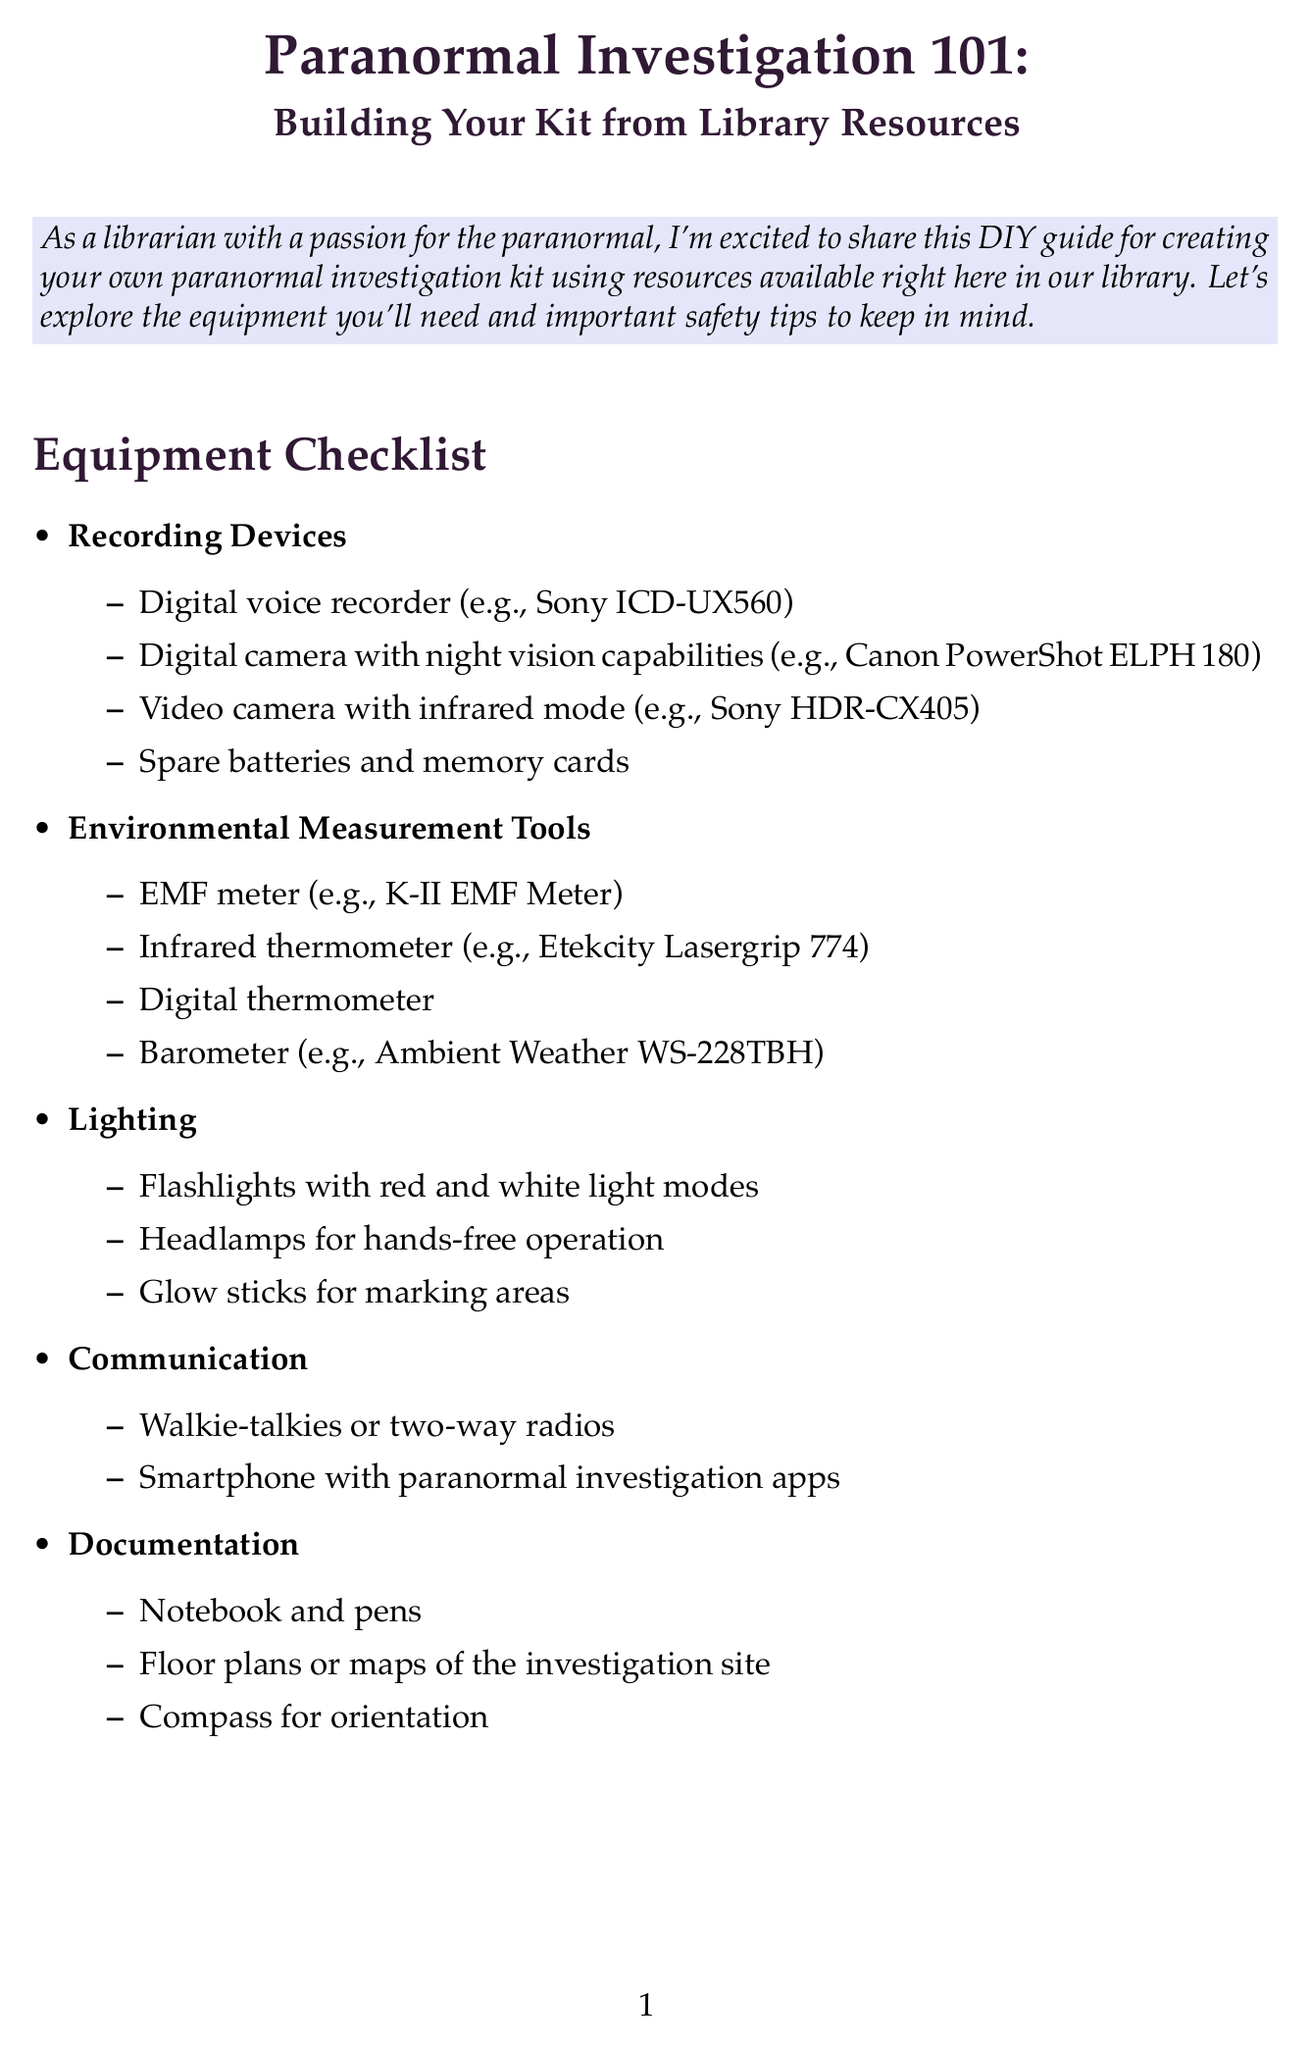What is the title of the newsletter? The title of the newsletter is prominently displayed at the beginning of the document.
Answer: Paranormal Investigation 101: Building Your Kit from Library Resources How many categories are in the equipment checklist? The equipment checklist is divided into categories, which are easily visible as section headers.
Answer: 5 What should you always carry during investigations? Safety tips outline essential items to bring when conducting investigations.
Answer: A first-aid kit Name one book recommended on paranormal investigation techniques. A list of suggested books is provided in the library resources section of the document.
Answer: "Ghost Hunting for Beginners" by Rich Newman What type of magazine is listed as a resource? The library resources section includes a variety of publication types, including magazines.
Answer: Fate Magazine What is the main purpose of the DIY section? The DIY section includes instructions for building specific equipment, which is detailed in the document.
Answer: To create equipment for investigations Name one safety tip provided in the document. Safety recommendations are listed clearly in their own section within the newsletter.
Answer: Investigate in teams of at least two people How should you modify an old radio for the spirit box? Instructions describe a specific modification process for the improvised spirit box in the DIY section.
Answer: Rapidly scan frequencies Which online database is suggested for academic articles? The library resources section includes names of databases that are available for use.
Answer: JSTOR 